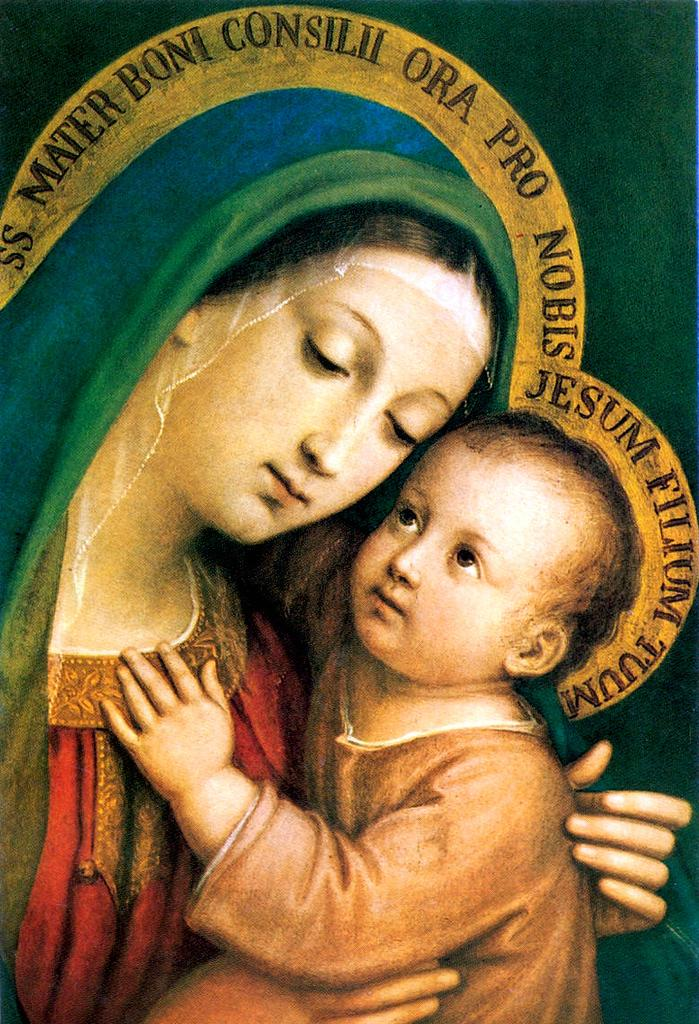What is depicted in the image? There is a picture of a woman and a kid in the image. What is the woman doing in the image? The woman is holding the kid in the image. What else can be seen in the image besides the pictures? There is text surrounding the pictures. How does the woman help the kid fly in the image? There is no indication in the image that the woman is helping the kid fly, as the image only shows the woman holding the kid. What type of insurance is mentioned in the text surrounding the pictures? There is no mention of insurance in the text surrounding the pictures. 